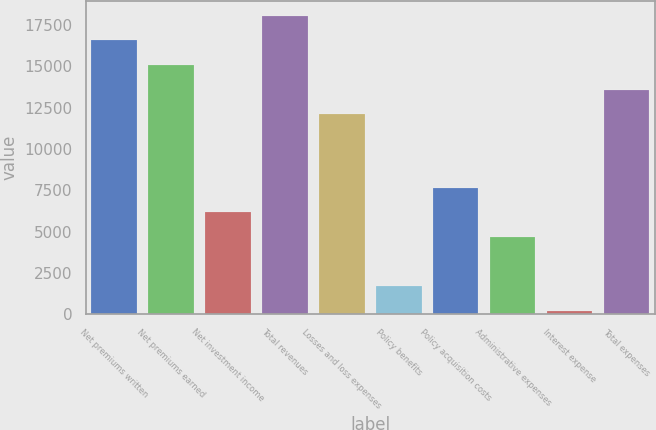Convert chart to OTSL. <chart><loc_0><loc_0><loc_500><loc_500><bar_chart><fcel>Net premiums written<fcel>Net premiums earned<fcel>Net investment income<fcel>Total revenues<fcel>Losses and loss expenses<fcel>Policy benefits<fcel>Policy acquisition costs<fcel>Administrative expenses<fcel>Interest expense<fcel>Total expenses<nl><fcel>16560<fcel>15075<fcel>6165<fcel>18045<fcel>12105<fcel>1710<fcel>7650<fcel>4680<fcel>225<fcel>13590<nl></chart> 